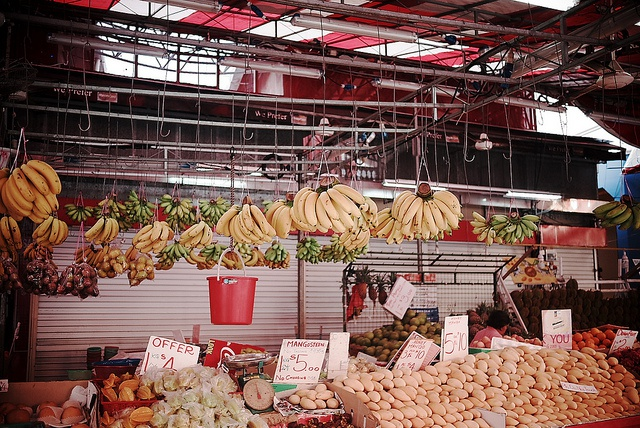Describe the objects in this image and their specific colors. I can see banana in black, tan, and maroon tones, banana in black, brown, maroon, and tan tones, banana in black and tan tones, banana in black, olive, and maroon tones, and banana in black, olive, and maroon tones in this image. 